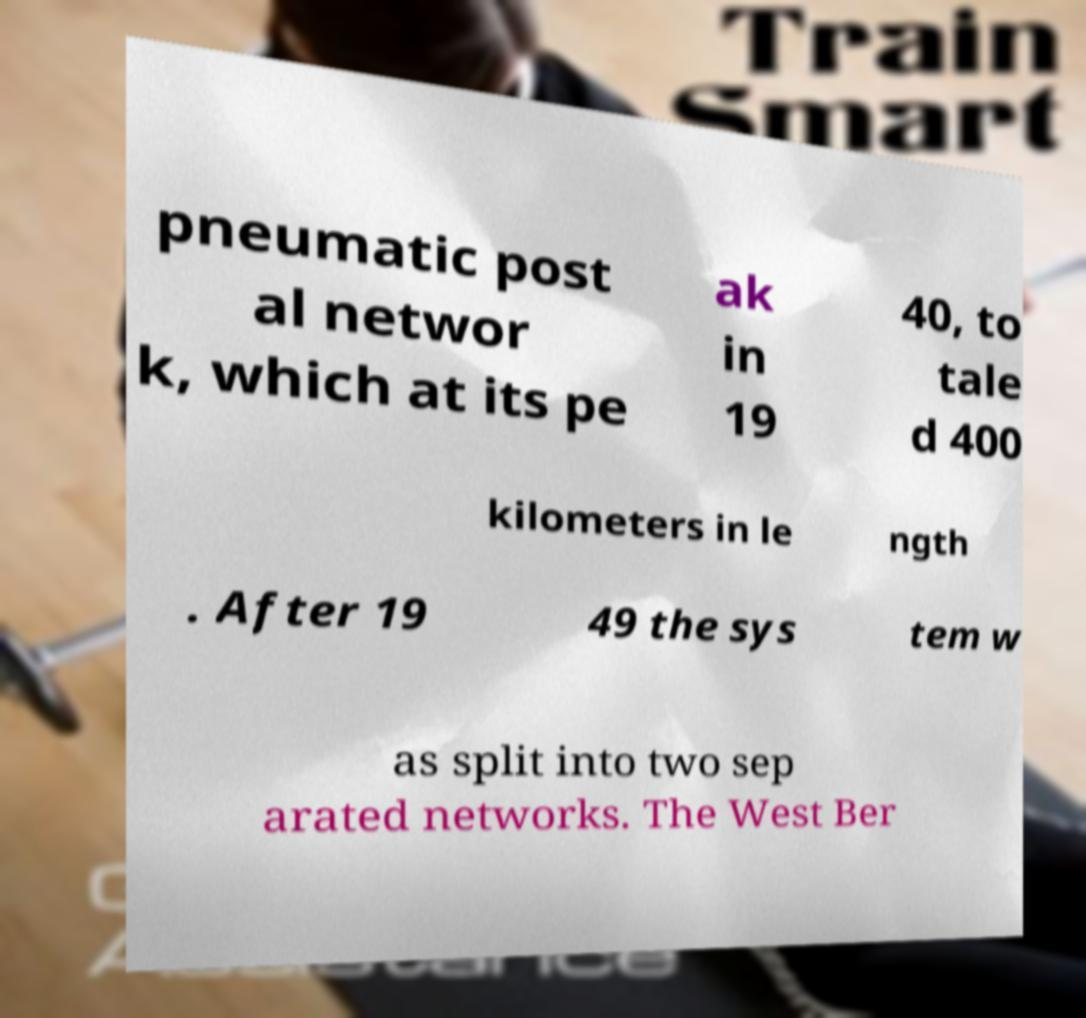Could you assist in decoding the text presented in this image and type it out clearly? pneumatic post al networ k, which at its pe ak in 19 40, to tale d 400 kilometers in le ngth . After 19 49 the sys tem w as split into two sep arated networks. The West Ber 